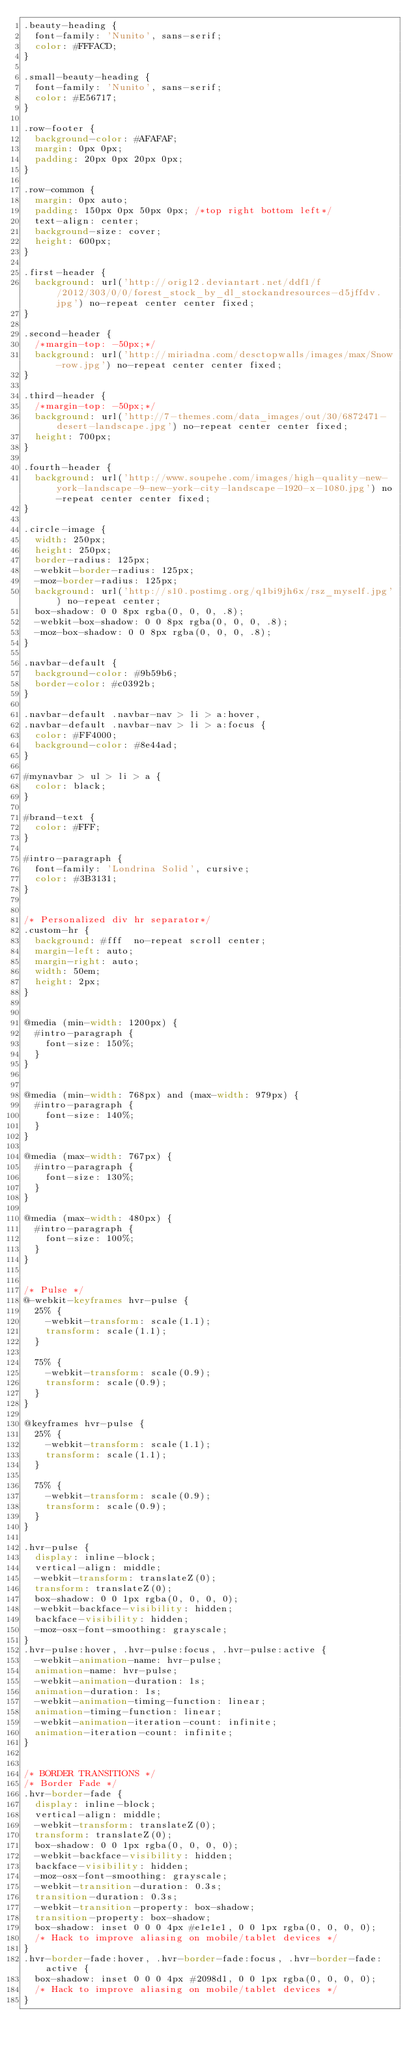<code> <loc_0><loc_0><loc_500><loc_500><_CSS_>.beauty-heading {
  font-family: 'Nunito', sans-serif;
  color: #FFFACD;
}

.small-beauty-heading {
  font-family: 'Nunito', sans-serif;
  color: #E56717;
}

.row-footer {
  background-color: #AFAFAF;
  margin: 0px 0px;
  padding: 20px 0px 20px 0px;
}

.row-common {
  margin: 0px auto;
  padding: 150px 0px 50px 0px; /*top right bottom left*/
  text-align: center;
  background-size: cover;
  height: 600px;
}

.first-header {
  background: url('http://orig12.deviantart.net/ddf1/f/2012/303/0/0/forest_stock_by_dl_stockandresources-d5jffdv.jpg') no-repeat center center fixed;
}

.second-header {
  /*margin-top: -50px;*/
  background: url('http://miriadna.com/desctopwalls/images/max/Snow-row.jpg') no-repeat center center fixed;
}

.third-header {
  /*margin-top: -50px;*/
  background: url('http://7-themes.com/data_images/out/30/6872471-desert-landscape.jpg') no-repeat center center fixed;
  height: 700px;
}

.fourth-header {
  background: url('http://www.soupehe.com/images/high-quality-new-york-landscape-9-new-york-city-landscape-1920-x-1080.jpg') no-repeat center center fixed;
}

.circle-image {
	width: 250px;
	height: 250px;
	border-radius: 125px;
	-webkit-border-radius: 125px;
	-moz-border-radius: 125px;
	background: url('http://s10.postimg.org/q1bi9jh6x/rsz_myself.jpg') no-repeat center;
  box-shadow: 0 0 8px rgba(0, 0, 0, .8);
  -webkit-box-shadow: 0 0 8px rgba(0, 0, 0, .8);
  -moz-box-shadow: 0 0 8px rgba(0, 0, 0, .8);
}

.navbar-default {
  background-color: #9b59b6;
  border-color: #c0392b;
}

.navbar-default .navbar-nav > li > a:hover,
.navbar-default .navbar-nav > li > a:focus {
  color: #FF4000;
  background-color: #8e44ad;
}

#mynavbar > ul > li > a {
  color: black;
}

#brand-text {
  color: #FFF;
}

#intro-paragraph {
  font-family: 'Londrina Solid', cursive;
  color: #3B3131;
}


/* Personalized div hr separator*/
.custom-hr {
  background: #fff  no-repeat scroll center;
  margin-left: auto;
  margin-right: auto;
  width: 50em;
  height: 2px;
}


@media (min-width: 1200px) {
  #intro-paragraph {
    font-size: 150%;
  }
}


@media (min-width: 768px) and (max-width: 979px) {
  #intro-paragraph {
    font-size: 140%;
  }
}

@media (max-width: 767px) {
  #intro-paragraph {
    font-size: 130%;
  }
}

@media (max-width: 480px) {
  #intro-paragraph {
    font-size: 100%;
  }
}


/* Pulse */
@-webkit-keyframes hvr-pulse {
  25% {
    -webkit-transform: scale(1.1);
    transform: scale(1.1);
  }

  75% {
    -webkit-transform: scale(0.9);
    transform: scale(0.9);
  }
}

@keyframes hvr-pulse {
  25% {
    -webkit-transform: scale(1.1);
    transform: scale(1.1);
  }

  75% {
    -webkit-transform: scale(0.9);
    transform: scale(0.9);
  }
}

.hvr-pulse {
  display: inline-block;
  vertical-align: middle;
  -webkit-transform: translateZ(0);
  transform: translateZ(0);
  box-shadow: 0 0 1px rgba(0, 0, 0, 0);
  -webkit-backface-visibility: hidden;
  backface-visibility: hidden;
  -moz-osx-font-smoothing: grayscale;
}
.hvr-pulse:hover, .hvr-pulse:focus, .hvr-pulse:active {
  -webkit-animation-name: hvr-pulse;
  animation-name: hvr-pulse;
  -webkit-animation-duration: 1s;
  animation-duration: 1s;
  -webkit-animation-timing-function: linear;
  animation-timing-function: linear;
  -webkit-animation-iteration-count: infinite;
  animation-iteration-count: infinite;
}


/* BORDER TRANSITIONS */
/* Border Fade */
.hvr-border-fade {
  display: inline-block;
  vertical-align: middle;
  -webkit-transform: translateZ(0);
  transform: translateZ(0);
  box-shadow: 0 0 1px rgba(0, 0, 0, 0);
  -webkit-backface-visibility: hidden;
  backface-visibility: hidden;
  -moz-osx-font-smoothing: grayscale;
  -webkit-transition-duration: 0.3s;
  transition-duration: 0.3s;
  -webkit-transition-property: box-shadow;
  transition-property: box-shadow;
  box-shadow: inset 0 0 0 4px #e1e1e1, 0 0 1px rgba(0, 0, 0, 0);
  /* Hack to improve aliasing on mobile/tablet devices */
}
.hvr-border-fade:hover, .hvr-border-fade:focus, .hvr-border-fade:active {
  box-shadow: inset 0 0 0 4px #2098d1, 0 0 1px rgba(0, 0, 0, 0);
  /* Hack to improve aliasing on mobile/tablet devices */
}
</code> 